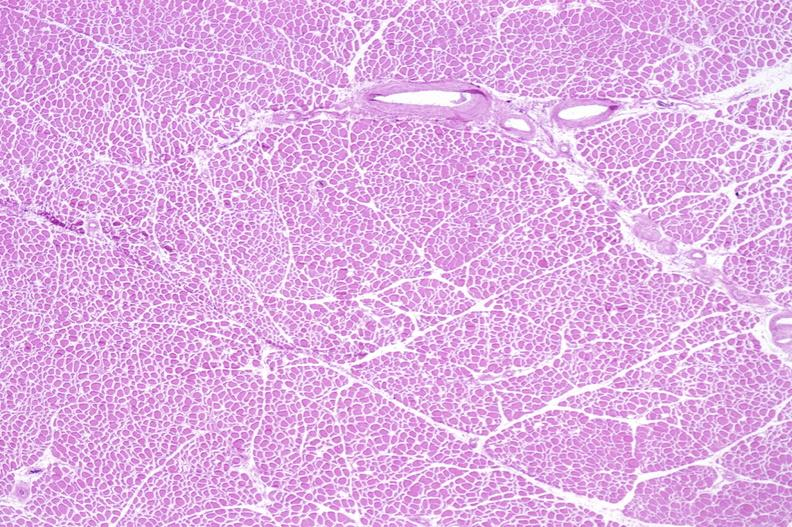what is present?
Answer the question using a single word or phrase. Soft tissue 